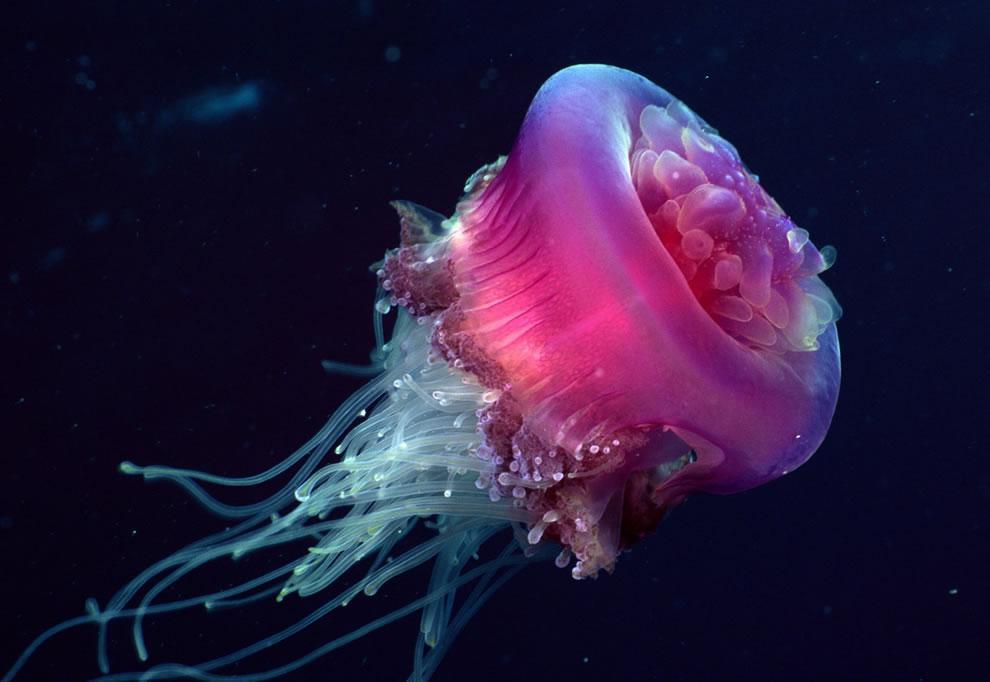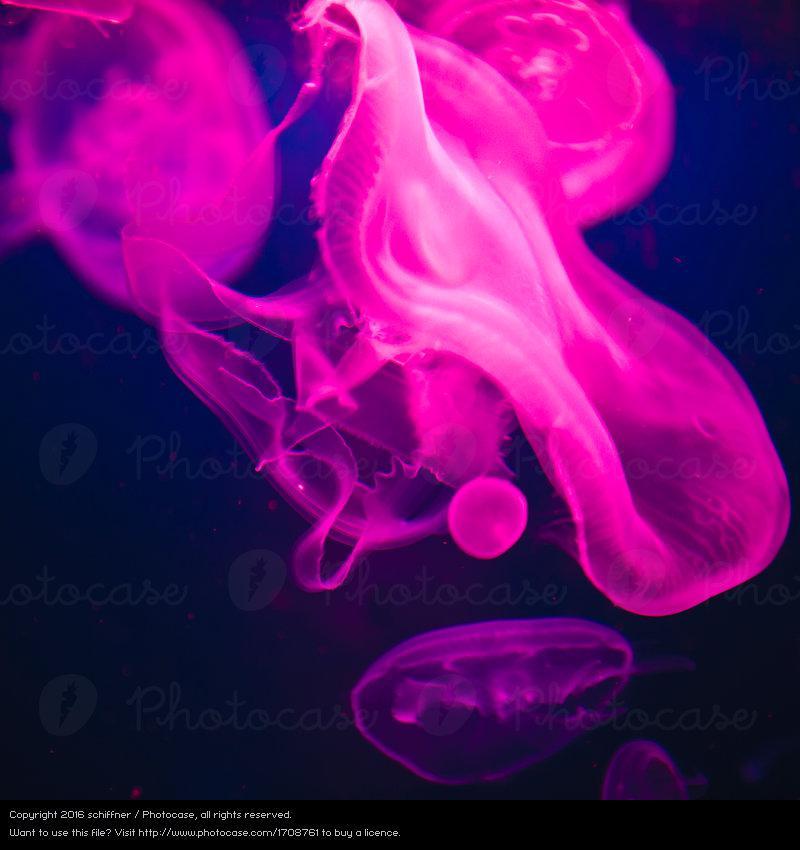The first image is the image on the left, the second image is the image on the right. Given the left and right images, does the statement "One of the images features exactly one jelly fish." hold true? Answer yes or no. Yes. The first image is the image on the left, the second image is the image on the right. Examine the images to the left and right. Is the description "An image shows multiple fluorescent pink jellyfish with tendrils trailing upward." accurate? Answer yes or no. No. 